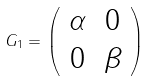Convert formula to latex. <formula><loc_0><loc_0><loc_500><loc_500>G _ { 1 } = \left ( \begin{array} { c c } \alpha & 0 \\ 0 & \beta \end{array} \right )</formula> 